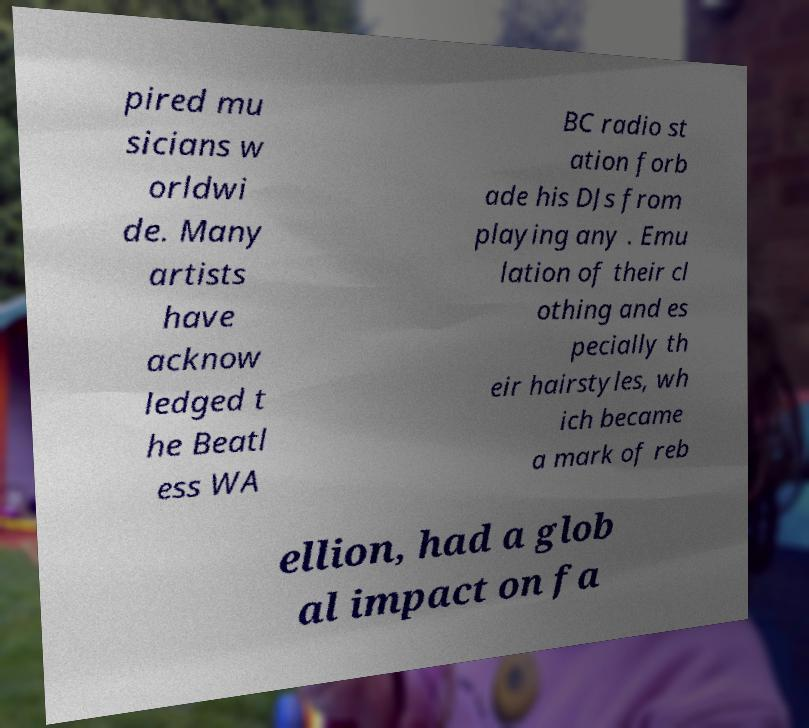What messages or text are displayed in this image? I need them in a readable, typed format. pired mu sicians w orldwi de. Many artists have acknow ledged t he Beatl ess WA BC radio st ation forb ade his DJs from playing any . Emu lation of their cl othing and es pecially th eir hairstyles, wh ich became a mark of reb ellion, had a glob al impact on fa 